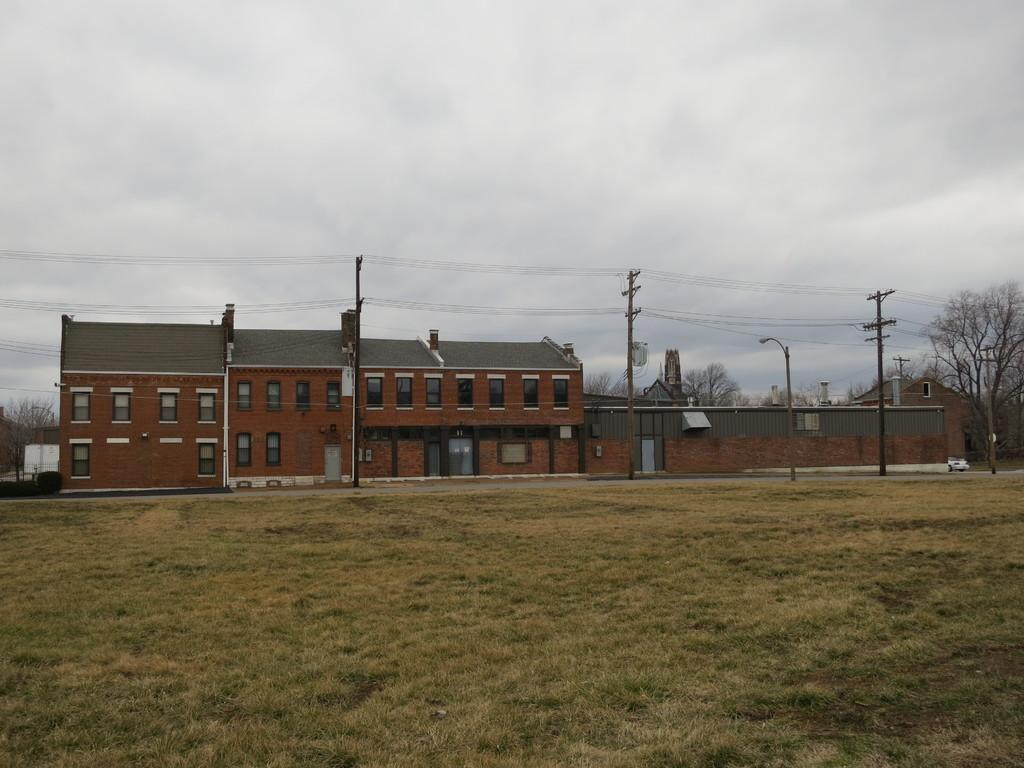What type of terrain is visible in the foreground of the image? There is grassland in the foreground of the image. What structure is located in the middle of the image? There is a building in the middle of the image. What else can be seen in the middle of the image besides the building? There are poles and cables in the middle of the image. What type of vegetation is visible in the background of the image? There are trees in the background of the image. What is visible at the top of the image? The sky is visible at the top of the image. How much territory does the building occupy in the image? The question about territory is not relevant to the image, as it does not involve any territorial claims or boundaries. How does the balance of the poles and cables affect the stability of the building in the image? The image does not provide any information about the balance or stability of the building, so this question cannot be answered definitively. 